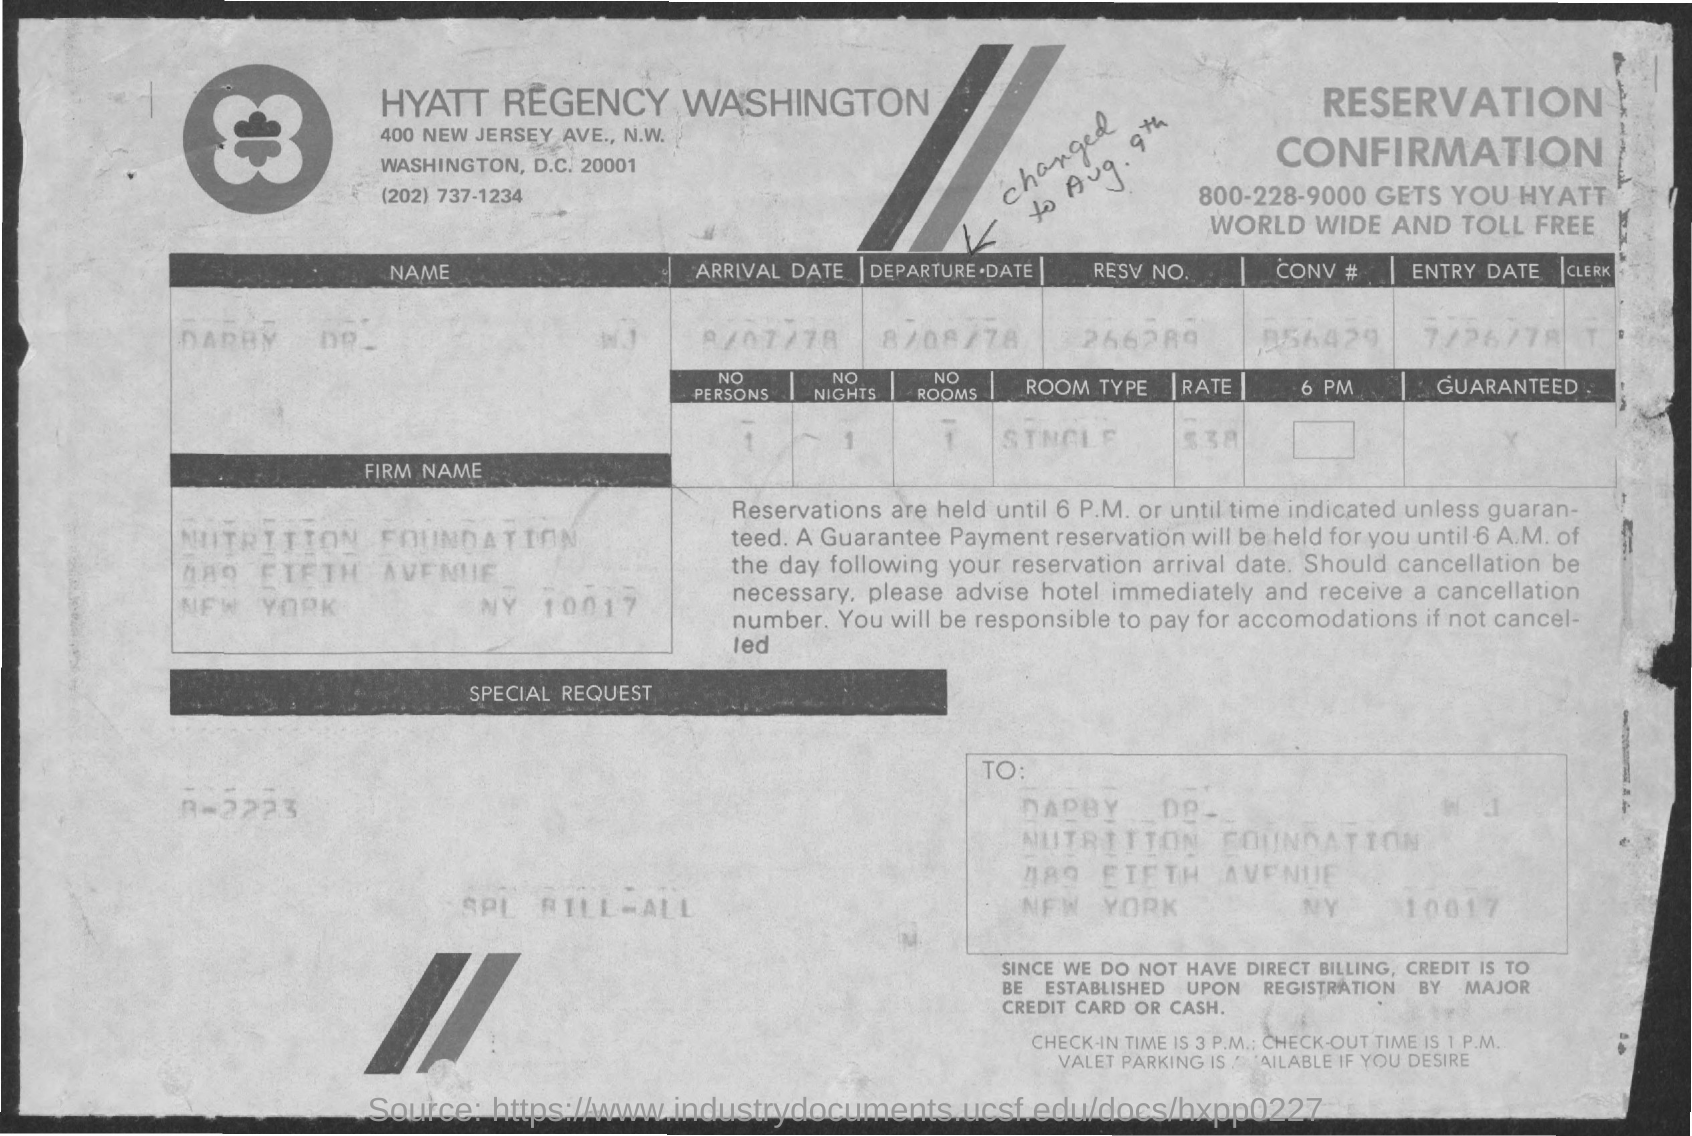Can you tell me the name of the hotel and its location as shown in the image? Certainly! The hotel is the Hyatt Regency Washington, located at 400 New Jersey Ave., N.W., in Washington, D.C., 20001, as indicated on the document. 